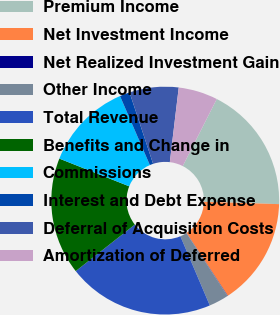Convert chart. <chart><loc_0><loc_0><loc_500><loc_500><pie_chart><fcel>Premium Income<fcel>Net Investment Income<fcel>Net Realized Investment Gain<fcel>Other Income<fcel>Total Revenue<fcel>Benefits and Change in<fcel>Commissions<fcel>Interest and Debt Expense<fcel>Deferral of Acquisition Costs<fcel>Amortization of Deferred<nl><fcel>18.02%<fcel>15.25%<fcel>0.05%<fcel>2.81%<fcel>20.78%<fcel>16.63%<fcel>12.49%<fcel>1.43%<fcel>6.96%<fcel>5.58%<nl></chart> 